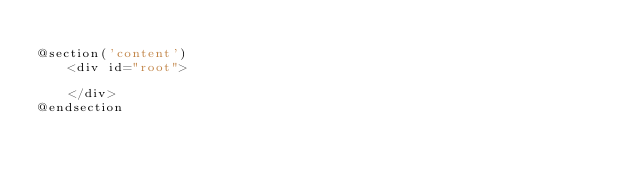<code> <loc_0><loc_0><loc_500><loc_500><_PHP_>
@section('content')
    <div id="root">
        
    </div>
@endsection
</code> 